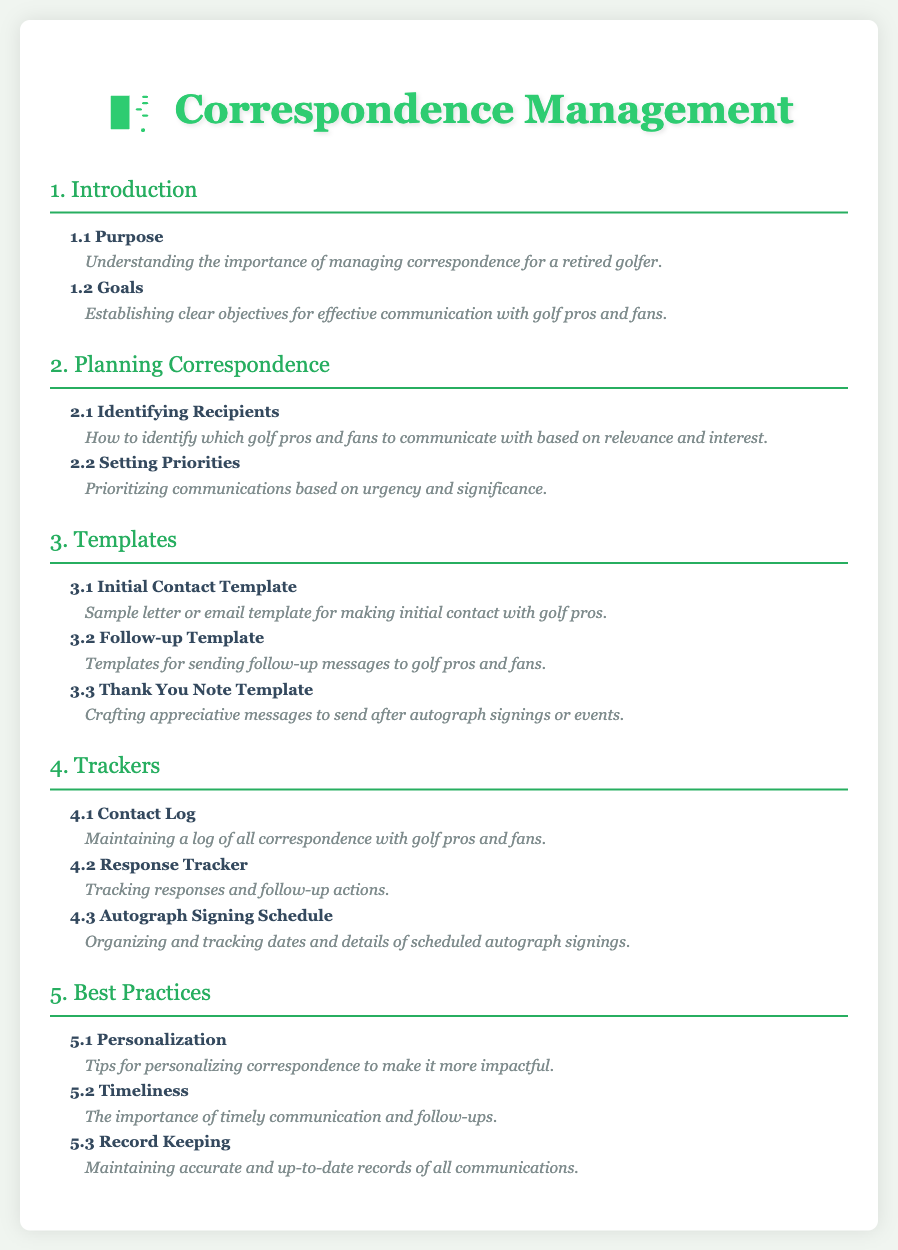What is the primary focus of section 1? Section 1 discusses the purpose and goals related to managing correspondence for a retired golfer.
Answer: Introduction How many templates are mentioned in section 3? Section 3 outlines three specific templates for correspondence.
Answer: 3 What is the topic of subsection 4.2? Subsection 4.2 deals with how to track responses and follow-up actions related to correspondence.
Answer: Response Tracker What is emphasized in subsection 5.1? Subsection 5.1 highlights the importance of personalizing correspondence to enhance its impact.
Answer: Personalization Which section covers the organizing of autograph signing dates? Section 4 includes tracking and organizing details concerning autograph signings.
Answer: Autograph Signing Schedule 